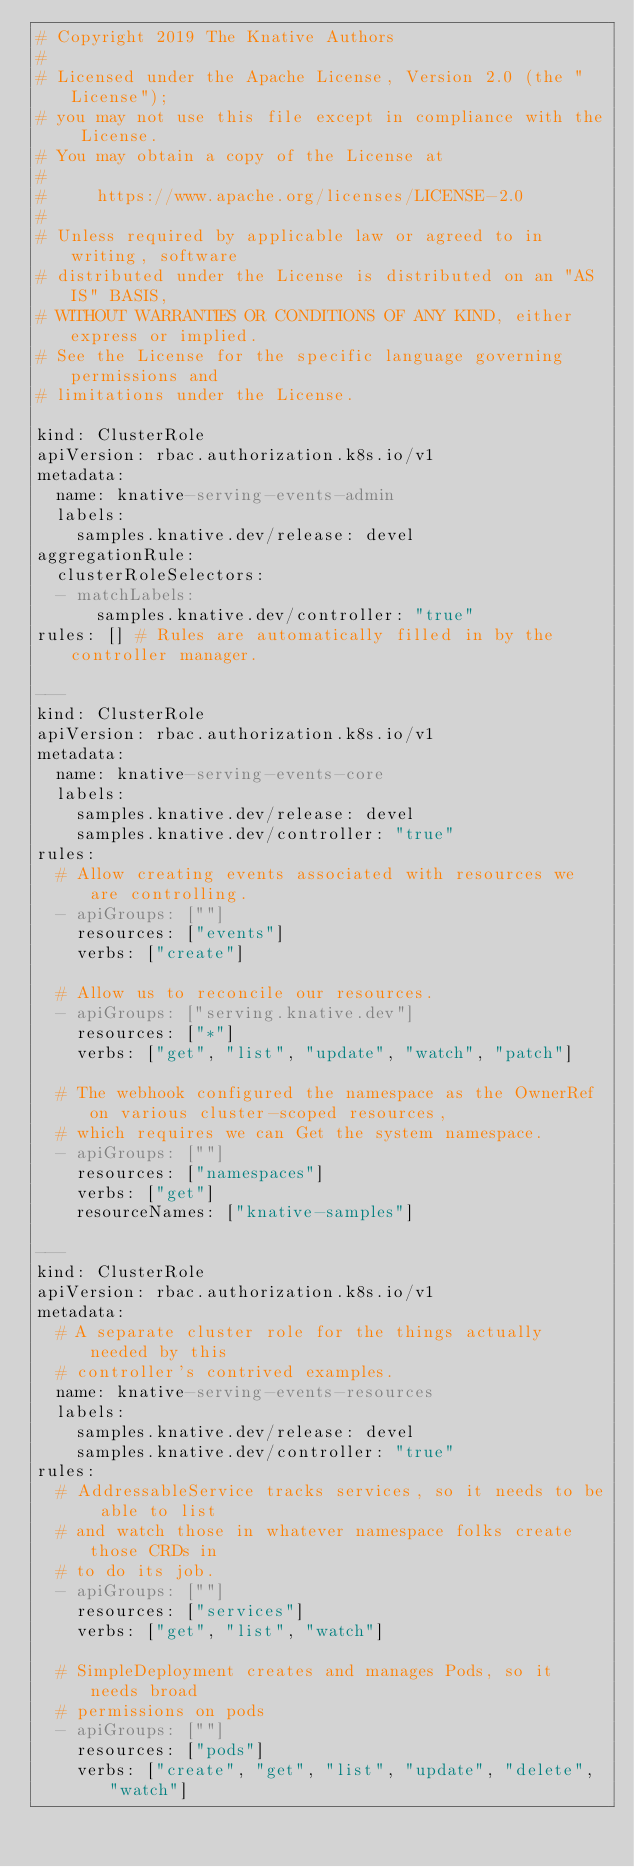<code> <loc_0><loc_0><loc_500><loc_500><_YAML_># Copyright 2019 The Knative Authors
#
# Licensed under the Apache License, Version 2.0 (the "License");
# you may not use this file except in compliance with the License.
# You may obtain a copy of the License at
#
#     https://www.apache.org/licenses/LICENSE-2.0
#
# Unless required by applicable law or agreed to in writing, software
# distributed under the License is distributed on an "AS IS" BASIS,
# WITHOUT WARRANTIES OR CONDITIONS OF ANY KIND, either express or implied.
# See the License for the specific language governing permissions and
# limitations under the License.

kind: ClusterRole
apiVersion: rbac.authorization.k8s.io/v1
metadata:
  name: knative-serving-events-admin
  labels:
    samples.knative.dev/release: devel
aggregationRule:
  clusterRoleSelectors:
  - matchLabels:
      samples.knative.dev/controller: "true"
rules: [] # Rules are automatically filled in by the controller manager.

---
kind: ClusterRole
apiVersion: rbac.authorization.k8s.io/v1
metadata:
  name: knative-serving-events-core
  labels:
    samples.knative.dev/release: devel
    samples.knative.dev/controller: "true"
rules:
  # Allow creating events associated with resources we are controlling.
  - apiGroups: [""]
    resources: ["events"]
    verbs: ["create"]

  # Allow us to reconcile our resources.
  - apiGroups: ["serving.knative.dev"]
    resources: ["*"]
    verbs: ["get", "list", "update", "watch", "patch"]

  # The webhook configured the namespace as the OwnerRef on various cluster-scoped resources,
  # which requires we can Get the system namespace.
  - apiGroups: [""]
    resources: ["namespaces"]
    verbs: ["get"]
    resourceNames: ["knative-samples"]

---
kind: ClusterRole
apiVersion: rbac.authorization.k8s.io/v1
metadata:
  # A separate cluster role for the things actually needed by this
  # controller's contrived examples.
  name: knative-serving-events-resources
  labels:
    samples.knative.dev/release: devel
    samples.knative.dev/controller: "true"
rules:
  # AddressableService tracks services, so it needs to be able to list
  # and watch those in whatever namespace folks create those CRDs in
  # to do its job.
  - apiGroups: [""]
    resources: ["services"]
    verbs: ["get", "list", "watch"]

  # SimpleDeployment creates and manages Pods, so it needs broad
  # permissions on pods
  - apiGroups: [""]
    resources: ["pods"]
    verbs: ["create", "get", "list", "update", "delete", "watch"]
</code> 